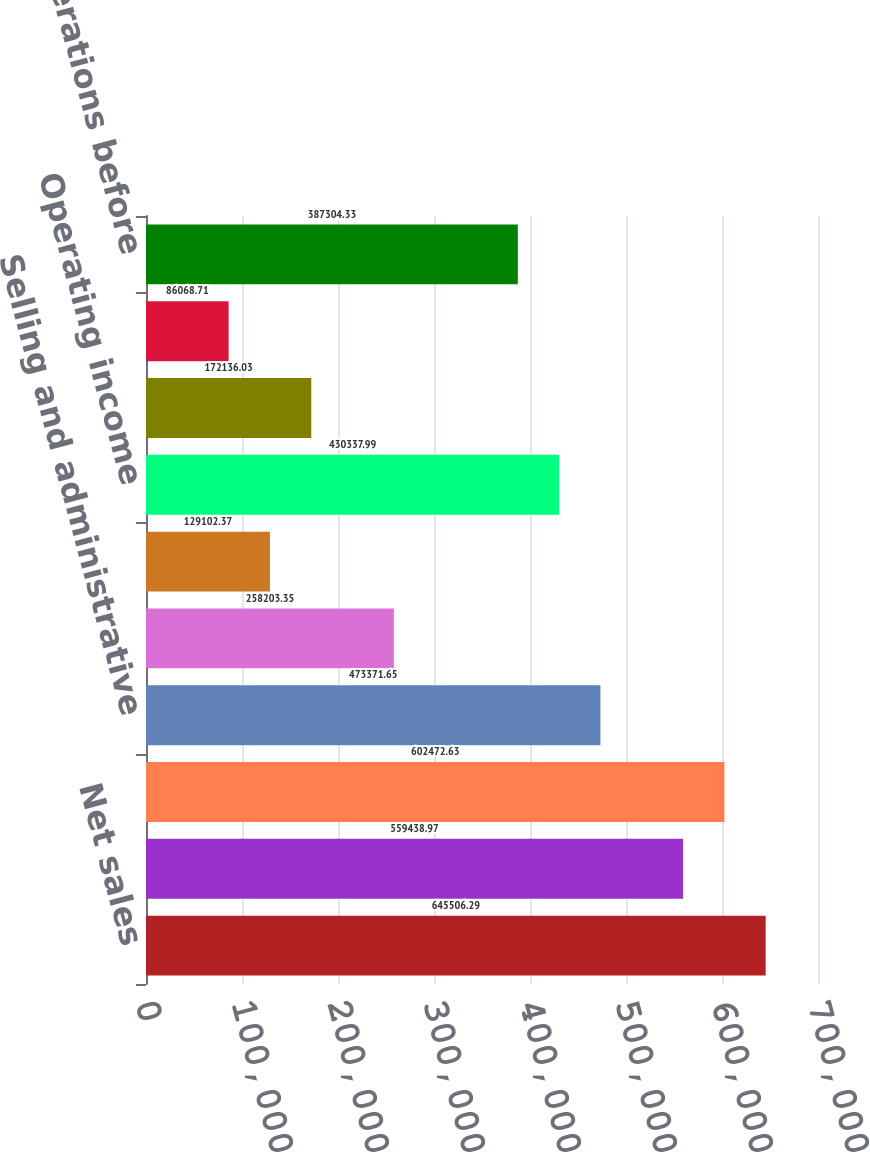<chart> <loc_0><loc_0><loc_500><loc_500><bar_chart><fcel>Net sales<fcel>Cost of sales<fcel>Gross profit<fcel>Selling and administrative<fcel>Research and development<fcel>Purchased intangibles<fcel>Operating income<fcel>Interest expense<fcel>Interest income<fcel>Income from operations before<nl><fcel>645506<fcel>559439<fcel>602473<fcel>473372<fcel>258203<fcel>129102<fcel>430338<fcel>172136<fcel>86068.7<fcel>387304<nl></chart> 